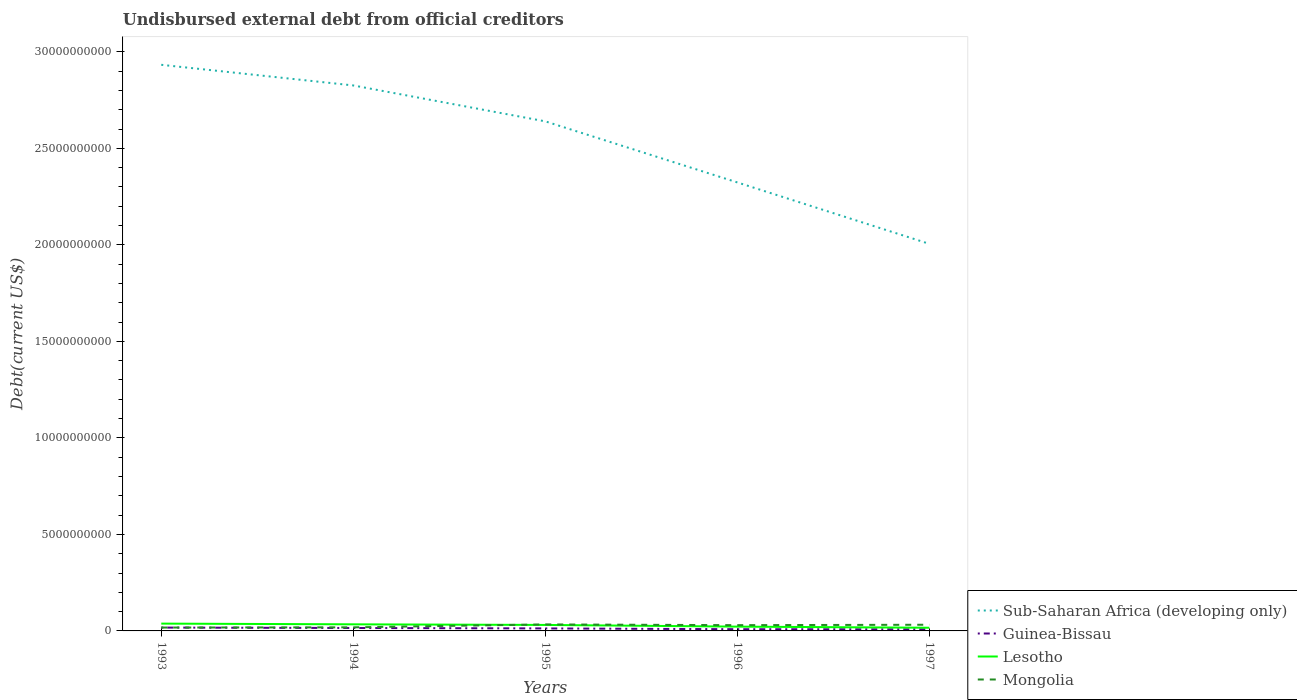How many different coloured lines are there?
Keep it short and to the point. 4. Across all years, what is the maximum total debt in Sub-Saharan Africa (developing only)?
Keep it short and to the point. 2.01e+1. In which year was the total debt in Sub-Saharan Africa (developing only) maximum?
Your response must be concise. 1997. What is the total total debt in Sub-Saharan Africa (developing only) in the graph?
Offer a very short reply. 6.09e+09. What is the difference between the highest and the second highest total debt in Guinea-Bissau?
Your answer should be compact. 8.95e+07. How many lines are there?
Offer a terse response. 4. What is the difference between two consecutive major ticks on the Y-axis?
Offer a terse response. 5.00e+09. Does the graph contain grids?
Provide a succinct answer. No. Where does the legend appear in the graph?
Keep it short and to the point. Bottom right. How are the legend labels stacked?
Provide a succinct answer. Vertical. What is the title of the graph?
Your answer should be compact. Undisbursed external debt from official creditors. Does "Guyana" appear as one of the legend labels in the graph?
Your answer should be compact. No. What is the label or title of the Y-axis?
Keep it short and to the point. Debt(current US$). What is the Debt(current US$) of Sub-Saharan Africa (developing only) in 1993?
Give a very brief answer. 2.93e+1. What is the Debt(current US$) in Guinea-Bissau in 1993?
Offer a very short reply. 1.73e+08. What is the Debt(current US$) in Lesotho in 1993?
Ensure brevity in your answer.  3.79e+08. What is the Debt(current US$) in Mongolia in 1993?
Provide a short and direct response. 1.74e+08. What is the Debt(current US$) of Sub-Saharan Africa (developing only) in 1994?
Your answer should be very brief. 2.83e+1. What is the Debt(current US$) of Guinea-Bissau in 1994?
Provide a succinct answer. 1.52e+08. What is the Debt(current US$) in Lesotho in 1994?
Ensure brevity in your answer.  3.41e+08. What is the Debt(current US$) in Mongolia in 1994?
Provide a short and direct response. 1.86e+08. What is the Debt(current US$) in Sub-Saharan Africa (developing only) in 1995?
Your answer should be compact. 2.64e+1. What is the Debt(current US$) of Guinea-Bissau in 1995?
Give a very brief answer. 1.30e+08. What is the Debt(current US$) in Lesotho in 1995?
Provide a succinct answer. 3.10e+08. What is the Debt(current US$) of Mongolia in 1995?
Provide a short and direct response. 3.37e+08. What is the Debt(current US$) of Sub-Saharan Africa (developing only) in 1996?
Offer a very short reply. 2.32e+1. What is the Debt(current US$) of Guinea-Bissau in 1996?
Keep it short and to the point. 8.90e+07. What is the Debt(current US$) in Lesotho in 1996?
Make the answer very short. 2.22e+08. What is the Debt(current US$) of Mongolia in 1996?
Your response must be concise. 2.99e+08. What is the Debt(current US$) in Sub-Saharan Africa (developing only) in 1997?
Make the answer very short. 2.01e+1. What is the Debt(current US$) in Guinea-Bissau in 1997?
Make the answer very short. 8.38e+07. What is the Debt(current US$) of Lesotho in 1997?
Provide a short and direct response. 1.65e+08. What is the Debt(current US$) of Mongolia in 1997?
Ensure brevity in your answer.  3.20e+08. Across all years, what is the maximum Debt(current US$) of Sub-Saharan Africa (developing only)?
Your response must be concise. 2.93e+1. Across all years, what is the maximum Debt(current US$) in Guinea-Bissau?
Keep it short and to the point. 1.73e+08. Across all years, what is the maximum Debt(current US$) in Lesotho?
Offer a terse response. 3.79e+08. Across all years, what is the maximum Debt(current US$) in Mongolia?
Give a very brief answer. 3.37e+08. Across all years, what is the minimum Debt(current US$) in Sub-Saharan Africa (developing only)?
Make the answer very short. 2.01e+1. Across all years, what is the minimum Debt(current US$) in Guinea-Bissau?
Offer a very short reply. 8.38e+07. Across all years, what is the minimum Debt(current US$) in Lesotho?
Your answer should be very brief. 1.65e+08. Across all years, what is the minimum Debt(current US$) of Mongolia?
Your answer should be compact. 1.74e+08. What is the total Debt(current US$) in Sub-Saharan Africa (developing only) in the graph?
Keep it short and to the point. 1.27e+11. What is the total Debt(current US$) of Guinea-Bissau in the graph?
Your answer should be very brief. 6.28e+08. What is the total Debt(current US$) of Lesotho in the graph?
Provide a succinct answer. 1.42e+09. What is the total Debt(current US$) of Mongolia in the graph?
Give a very brief answer. 1.32e+09. What is the difference between the Debt(current US$) of Sub-Saharan Africa (developing only) in 1993 and that in 1994?
Ensure brevity in your answer.  1.07e+09. What is the difference between the Debt(current US$) of Guinea-Bissau in 1993 and that in 1994?
Offer a very short reply. 2.16e+07. What is the difference between the Debt(current US$) of Lesotho in 1993 and that in 1994?
Keep it short and to the point. 3.74e+07. What is the difference between the Debt(current US$) of Mongolia in 1993 and that in 1994?
Your answer should be compact. -1.19e+07. What is the difference between the Debt(current US$) of Sub-Saharan Africa (developing only) in 1993 and that in 1995?
Ensure brevity in your answer.  2.93e+09. What is the difference between the Debt(current US$) of Guinea-Bissau in 1993 and that in 1995?
Provide a short and direct response. 4.35e+07. What is the difference between the Debt(current US$) in Lesotho in 1993 and that in 1995?
Keep it short and to the point. 6.91e+07. What is the difference between the Debt(current US$) in Mongolia in 1993 and that in 1995?
Make the answer very short. -1.63e+08. What is the difference between the Debt(current US$) in Sub-Saharan Africa (developing only) in 1993 and that in 1996?
Your answer should be very brief. 6.09e+09. What is the difference between the Debt(current US$) of Guinea-Bissau in 1993 and that in 1996?
Your answer should be compact. 8.43e+07. What is the difference between the Debt(current US$) of Lesotho in 1993 and that in 1996?
Provide a short and direct response. 1.56e+08. What is the difference between the Debt(current US$) in Mongolia in 1993 and that in 1996?
Keep it short and to the point. -1.25e+08. What is the difference between the Debt(current US$) in Sub-Saharan Africa (developing only) in 1993 and that in 1997?
Offer a terse response. 9.28e+09. What is the difference between the Debt(current US$) of Guinea-Bissau in 1993 and that in 1997?
Give a very brief answer. 8.95e+07. What is the difference between the Debt(current US$) in Lesotho in 1993 and that in 1997?
Ensure brevity in your answer.  2.14e+08. What is the difference between the Debt(current US$) in Mongolia in 1993 and that in 1997?
Ensure brevity in your answer.  -1.46e+08. What is the difference between the Debt(current US$) of Sub-Saharan Africa (developing only) in 1994 and that in 1995?
Your answer should be compact. 1.86e+09. What is the difference between the Debt(current US$) in Guinea-Bissau in 1994 and that in 1995?
Offer a terse response. 2.19e+07. What is the difference between the Debt(current US$) in Lesotho in 1994 and that in 1995?
Offer a very short reply. 3.17e+07. What is the difference between the Debt(current US$) in Mongolia in 1994 and that in 1995?
Your answer should be compact. -1.51e+08. What is the difference between the Debt(current US$) of Sub-Saharan Africa (developing only) in 1994 and that in 1996?
Your response must be concise. 5.02e+09. What is the difference between the Debt(current US$) of Guinea-Bissau in 1994 and that in 1996?
Ensure brevity in your answer.  6.27e+07. What is the difference between the Debt(current US$) in Lesotho in 1994 and that in 1996?
Your response must be concise. 1.19e+08. What is the difference between the Debt(current US$) of Mongolia in 1994 and that in 1996?
Ensure brevity in your answer.  -1.13e+08. What is the difference between the Debt(current US$) of Sub-Saharan Africa (developing only) in 1994 and that in 1997?
Make the answer very short. 8.21e+09. What is the difference between the Debt(current US$) in Guinea-Bissau in 1994 and that in 1997?
Offer a very short reply. 6.80e+07. What is the difference between the Debt(current US$) of Lesotho in 1994 and that in 1997?
Provide a short and direct response. 1.76e+08. What is the difference between the Debt(current US$) of Mongolia in 1994 and that in 1997?
Give a very brief answer. -1.34e+08. What is the difference between the Debt(current US$) of Sub-Saharan Africa (developing only) in 1995 and that in 1996?
Your answer should be very brief. 3.16e+09. What is the difference between the Debt(current US$) in Guinea-Bissau in 1995 and that in 1996?
Offer a terse response. 4.08e+07. What is the difference between the Debt(current US$) in Lesotho in 1995 and that in 1996?
Your response must be concise. 8.72e+07. What is the difference between the Debt(current US$) of Mongolia in 1995 and that in 1996?
Provide a succinct answer. 3.85e+07. What is the difference between the Debt(current US$) of Sub-Saharan Africa (developing only) in 1995 and that in 1997?
Your response must be concise. 6.35e+09. What is the difference between the Debt(current US$) of Guinea-Bissau in 1995 and that in 1997?
Your response must be concise. 4.61e+07. What is the difference between the Debt(current US$) of Lesotho in 1995 and that in 1997?
Provide a succinct answer. 1.44e+08. What is the difference between the Debt(current US$) in Mongolia in 1995 and that in 1997?
Ensure brevity in your answer.  1.72e+07. What is the difference between the Debt(current US$) in Sub-Saharan Africa (developing only) in 1996 and that in 1997?
Your answer should be compact. 3.18e+09. What is the difference between the Debt(current US$) of Guinea-Bissau in 1996 and that in 1997?
Keep it short and to the point. 5.23e+06. What is the difference between the Debt(current US$) in Lesotho in 1996 and that in 1997?
Ensure brevity in your answer.  5.73e+07. What is the difference between the Debt(current US$) of Mongolia in 1996 and that in 1997?
Provide a succinct answer. -2.14e+07. What is the difference between the Debt(current US$) of Sub-Saharan Africa (developing only) in 1993 and the Debt(current US$) of Guinea-Bissau in 1994?
Your answer should be compact. 2.92e+1. What is the difference between the Debt(current US$) of Sub-Saharan Africa (developing only) in 1993 and the Debt(current US$) of Lesotho in 1994?
Ensure brevity in your answer.  2.90e+1. What is the difference between the Debt(current US$) in Sub-Saharan Africa (developing only) in 1993 and the Debt(current US$) in Mongolia in 1994?
Provide a succinct answer. 2.91e+1. What is the difference between the Debt(current US$) in Guinea-Bissau in 1993 and the Debt(current US$) in Lesotho in 1994?
Your response must be concise. -1.68e+08. What is the difference between the Debt(current US$) in Guinea-Bissau in 1993 and the Debt(current US$) in Mongolia in 1994?
Your answer should be very brief. -1.27e+07. What is the difference between the Debt(current US$) in Lesotho in 1993 and the Debt(current US$) in Mongolia in 1994?
Provide a short and direct response. 1.93e+08. What is the difference between the Debt(current US$) in Sub-Saharan Africa (developing only) in 1993 and the Debt(current US$) in Guinea-Bissau in 1995?
Offer a terse response. 2.92e+1. What is the difference between the Debt(current US$) of Sub-Saharan Africa (developing only) in 1993 and the Debt(current US$) of Lesotho in 1995?
Your response must be concise. 2.90e+1. What is the difference between the Debt(current US$) in Sub-Saharan Africa (developing only) in 1993 and the Debt(current US$) in Mongolia in 1995?
Make the answer very short. 2.90e+1. What is the difference between the Debt(current US$) in Guinea-Bissau in 1993 and the Debt(current US$) in Lesotho in 1995?
Provide a short and direct response. -1.36e+08. What is the difference between the Debt(current US$) in Guinea-Bissau in 1993 and the Debt(current US$) in Mongolia in 1995?
Offer a terse response. -1.64e+08. What is the difference between the Debt(current US$) of Lesotho in 1993 and the Debt(current US$) of Mongolia in 1995?
Make the answer very short. 4.16e+07. What is the difference between the Debt(current US$) in Sub-Saharan Africa (developing only) in 1993 and the Debt(current US$) in Guinea-Bissau in 1996?
Ensure brevity in your answer.  2.92e+1. What is the difference between the Debt(current US$) of Sub-Saharan Africa (developing only) in 1993 and the Debt(current US$) of Lesotho in 1996?
Offer a terse response. 2.91e+1. What is the difference between the Debt(current US$) of Sub-Saharan Africa (developing only) in 1993 and the Debt(current US$) of Mongolia in 1996?
Keep it short and to the point. 2.90e+1. What is the difference between the Debt(current US$) of Guinea-Bissau in 1993 and the Debt(current US$) of Lesotho in 1996?
Give a very brief answer. -4.92e+07. What is the difference between the Debt(current US$) in Guinea-Bissau in 1993 and the Debt(current US$) in Mongolia in 1996?
Make the answer very short. -1.25e+08. What is the difference between the Debt(current US$) of Lesotho in 1993 and the Debt(current US$) of Mongolia in 1996?
Your response must be concise. 8.01e+07. What is the difference between the Debt(current US$) in Sub-Saharan Africa (developing only) in 1993 and the Debt(current US$) in Guinea-Bissau in 1997?
Your response must be concise. 2.92e+1. What is the difference between the Debt(current US$) of Sub-Saharan Africa (developing only) in 1993 and the Debt(current US$) of Lesotho in 1997?
Provide a succinct answer. 2.92e+1. What is the difference between the Debt(current US$) of Sub-Saharan Africa (developing only) in 1993 and the Debt(current US$) of Mongolia in 1997?
Provide a short and direct response. 2.90e+1. What is the difference between the Debt(current US$) in Guinea-Bissau in 1993 and the Debt(current US$) in Lesotho in 1997?
Offer a terse response. 8.10e+06. What is the difference between the Debt(current US$) of Guinea-Bissau in 1993 and the Debt(current US$) of Mongolia in 1997?
Offer a terse response. -1.47e+08. What is the difference between the Debt(current US$) in Lesotho in 1993 and the Debt(current US$) in Mongolia in 1997?
Give a very brief answer. 5.87e+07. What is the difference between the Debt(current US$) in Sub-Saharan Africa (developing only) in 1994 and the Debt(current US$) in Guinea-Bissau in 1995?
Keep it short and to the point. 2.81e+1. What is the difference between the Debt(current US$) in Sub-Saharan Africa (developing only) in 1994 and the Debt(current US$) in Lesotho in 1995?
Provide a succinct answer. 2.80e+1. What is the difference between the Debt(current US$) of Sub-Saharan Africa (developing only) in 1994 and the Debt(current US$) of Mongolia in 1995?
Ensure brevity in your answer.  2.79e+1. What is the difference between the Debt(current US$) in Guinea-Bissau in 1994 and the Debt(current US$) in Lesotho in 1995?
Your response must be concise. -1.58e+08. What is the difference between the Debt(current US$) of Guinea-Bissau in 1994 and the Debt(current US$) of Mongolia in 1995?
Provide a succinct answer. -1.85e+08. What is the difference between the Debt(current US$) in Lesotho in 1994 and the Debt(current US$) in Mongolia in 1995?
Offer a very short reply. 4.15e+06. What is the difference between the Debt(current US$) of Sub-Saharan Africa (developing only) in 1994 and the Debt(current US$) of Guinea-Bissau in 1996?
Keep it short and to the point. 2.82e+1. What is the difference between the Debt(current US$) in Sub-Saharan Africa (developing only) in 1994 and the Debt(current US$) in Lesotho in 1996?
Your answer should be compact. 2.80e+1. What is the difference between the Debt(current US$) of Sub-Saharan Africa (developing only) in 1994 and the Debt(current US$) of Mongolia in 1996?
Offer a terse response. 2.80e+1. What is the difference between the Debt(current US$) in Guinea-Bissau in 1994 and the Debt(current US$) in Lesotho in 1996?
Your response must be concise. -7.07e+07. What is the difference between the Debt(current US$) of Guinea-Bissau in 1994 and the Debt(current US$) of Mongolia in 1996?
Offer a very short reply. -1.47e+08. What is the difference between the Debt(current US$) in Lesotho in 1994 and the Debt(current US$) in Mongolia in 1996?
Your answer should be very brief. 4.27e+07. What is the difference between the Debt(current US$) in Sub-Saharan Africa (developing only) in 1994 and the Debt(current US$) in Guinea-Bissau in 1997?
Keep it short and to the point. 2.82e+1. What is the difference between the Debt(current US$) of Sub-Saharan Africa (developing only) in 1994 and the Debt(current US$) of Lesotho in 1997?
Give a very brief answer. 2.81e+1. What is the difference between the Debt(current US$) in Sub-Saharan Africa (developing only) in 1994 and the Debt(current US$) in Mongolia in 1997?
Give a very brief answer. 2.79e+1. What is the difference between the Debt(current US$) in Guinea-Bissau in 1994 and the Debt(current US$) in Lesotho in 1997?
Keep it short and to the point. -1.35e+07. What is the difference between the Debt(current US$) of Guinea-Bissau in 1994 and the Debt(current US$) of Mongolia in 1997?
Offer a very short reply. -1.68e+08. What is the difference between the Debt(current US$) in Lesotho in 1994 and the Debt(current US$) in Mongolia in 1997?
Your answer should be very brief. 2.13e+07. What is the difference between the Debt(current US$) in Sub-Saharan Africa (developing only) in 1995 and the Debt(current US$) in Guinea-Bissau in 1996?
Keep it short and to the point. 2.63e+1. What is the difference between the Debt(current US$) of Sub-Saharan Africa (developing only) in 1995 and the Debt(current US$) of Lesotho in 1996?
Offer a terse response. 2.62e+1. What is the difference between the Debt(current US$) in Sub-Saharan Africa (developing only) in 1995 and the Debt(current US$) in Mongolia in 1996?
Your response must be concise. 2.61e+1. What is the difference between the Debt(current US$) in Guinea-Bissau in 1995 and the Debt(current US$) in Lesotho in 1996?
Make the answer very short. -9.26e+07. What is the difference between the Debt(current US$) in Guinea-Bissau in 1995 and the Debt(current US$) in Mongolia in 1996?
Offer a very short reply. -1.69e+08. What is the difference between the Debt(current US$) in Lesotho in 1995 and the Debt(current US$) in Mongolia in 1996?
Ensure brevity in your answer.  1.10e+07. What is the difference between the Debt(current US$) in Sub-Saharan Africa (developing only) in 1995 and the Debt(current US$) in Guinea-Bissau in 1997?
Offer a terse response. 2.63e+1. What is the difference between the Debt(current US$) in Sub-Saharan Africa (developing only) in 1995 and the Debt(current US$) in Lesotho in 1997?
Offer a very short reply. 2.62e+1. What is the difference between the Debt(current US$) of Sub-Saharan Africa (developing only) in 1995 and the Debt(current US$) of Mongolia in 1997?
Keep it short and to the point. 2.61e+1. What is the difference between the Debt(current US$) in Guinea-Bissau in 1995 and the Debt(current US$) in Lesotho in 1997?
Offer a very short reply. -3.54e+07. What is the difference between the Debt(current US$) in Guinea-Bissau in 1995 and the Debt(current US$) in Mongolia in 1997?
Your response must be concise. -1.90e+08. What is the difference between the Debt(current US$) of Lesotho in 1995 and the Debt(current US$) of Mongolia in 1997?
Offer a terse response. -1.04e+07. What is the difference between the Debt(current US$) in Sub-Saharan Africa (developing only) in 1996 and the Debt(current US$) in Guinea-Bissau in 1997?
Ensure brevity in your answer.  2.32e+1. What is the difference between the Debt(current US$) in Sub-Saharan Africa (developing only) in 1996 and the Debt(current US$) in Lesotho in 1997?
Ensure brevity in your answer.  2.31e+1. What is the difference between the Debt(current US$) in Sub-Saharan Africa (developing only) in 1996 and the Debt(current US$) in Mongolia in 1997?
Offer a very short reply. 2.29e+1. What is the difference between the Debt(current US$) of Guinea-Bissau in 1996 and the Debt(current US$) of Lesotho in 1997?
Your response must be concise. -7.62e+07. What is the difference between the Debt(current US$) in Guinea-Bissau in 1996 and the Debt(current US$) in Mongolia in 1997?
Offer a very short reply. -2.31e+08. What is the difference between the Debt(current US$) in Lesotho in 1996 and the Debt(current US$) in Mongolia in 1997?
Give a very brief answer. -9.76e+07. What is the average Debt(current US$) in Sub-Saharan Africa (developing only) per year?
Make the answer very short. 2.55e+1. What is the average Debt(current US$) of Guinea-Bissau per year?
Provide a short and direct response. 1.26e+08. What is the average Debt(current US$) of Lesotho per year?
Give a very brief answer. 2.83e+08. What is the average Debt(current US$) of Mongolia per year?
Your response must be concise. 2.63e+08. In the year 1993, what is the difference between the Debt(current US$) in Sub-Saharan Africa (developing only) and Debt(current US$) in Guinea-Bissau?
Your response must be concise. 2.92e+1. In the year 1993, what is the difference between the Debt(current US$) in Sub-Saharan Africa (developing only) and Debt(current US$) in Lesotho?
Your answer should be very brief. 2.90e+1. In the year 1993, what is the difference between the Debt(current US$) of Sub-Saharan Africa (developing only) and Debt(current US$) of Mongolia?
Offer a terse response. 2.92e+1. In the year 1993, what is the difference between the Debt(current US$) of Guinea-Bissau and Debt(current US$) of Lesotho?
Provide a short and direct response. -2.05e+08. In the year 1993, what is the difference between the Debt(current US$) of Guinea-Bissau and Debt(current US$) of Mongolia?
Ensure brevity in your answer.  -8.41e+05. In the year 1993, what is the difference between the Debt(current US$) of Lesotho and Debt(current US$) of Mongolia?
Ensure brevity in your answer.  2.05e+08. In the year 1994, what is the difference between the Debt(current US$) in Sub-Saharan Africa (developing only) and Debt(current US$) in Guinea-Bissau?
Make the answer very short. 2.81e+1. In the year 1994, what is the difference between the Debt(current US$) of Sub-Saharan Africa (developing only) and Debt(current US$) of Lesotho?
Give a very brief answer. 2.79e+1. In the year 1994, what is the difference between the Debt(current US$) in Sub-Saharan Africa (developing only) and Debt(current US$) in Mongolia?
Keep it short and to the point. 2.81e+1. In the year 1994, what is the difference between the Debt(current US$) in Guinea-Bissau and Debt(current US$) in Lesotho?
Offer a terse response. -1.90e+08. In the year 1994, what is the difference between the Debt(current US$) of Guinea-Bissau and Debt(current US$) of Mongolia?
Provide a succinct answer. -3.43e+07. In the year 1994, what is the difference between the Debt(current US$) of Lesotho and Debt(current US$) of Mongolia?
Your answer should be very brief. 1.55e+08. In the year 1995, what is the difference between the Debt(current US$) of Sub-Saharan Africa (developing only) and Debt(current US$) of Guinea-Bissau?
Your answer should be compact. 2.63e+1. In the year 1995, what is the difference between the Debt(current US$) in Sub-Saharan Africa (developing only) and Debt(current US$) in Lesotho?
Provide a succinct answer. 2.61e+1. In the year 1995, what is the difference between the Debt(current US$) of Sub-Saharan Africa (developing only) and Debt(current US$) of Mongolia?
Your response must be concise. 2.61e+1. In the year 1995, what is the difference between the Debt(current US$) in Guinea-Bissau and Debt(current US$) in Lesotho?
Provide a succinct answer. -1.80e+08. In the year 1995, what is the difference between the Debt(current US$) in Guinea-Bissau and Debt(current US$) in Mongolia?
Provide a short and direct response. -2.07e+08. In the year 1995, what is the difference between the Debt(current US$) of Lesotho and Debt(current US$) of Mongolia?
Offer a very short reply. -2.75e+07. In the year 1996, what is the difference between the Debt(current US$) of Sub-Saharan Africa (developing only) and Debt(current US$) of Guinea-Bissau?
Offer a very short reply. 2.31e+1. In the year 1996, what is the difference between the Debt(current US$) in Sub-Saharan Africa (developing only) and Debt(current US$) in Lesotho?
Ensure brevity in your answer.  2.30e+1. In the year 1996, what is the difference between the Debt(current US$) of Sub-Saharan Africa (developing only) and Debt(current US$) of Mongolia?
Your answer should be compact. 2.29e+1. In the year 1996, what is the difference between the Debt(current US$) in Guinea-Bissau and Debt(current US$) in Lesotho?
Your answer should be very brief. -1.33e+08. In the year 1996, what is the difference between the Debt(current US$) of Guinea-Bissau and Debt(current US$) of Mongolia?
Your response must be concise. -2.10e+08. In the year 1996, what is the difference between the Debt(current US$) in Lesotho and Debt(current US$) in Mongolia?
Your response must be concise. -7.62e+07. In the year 1997, what is the difference between the Debt(current US$) of Sub-Saharan Africa (developing only) and Debt(current US$) of Guinea-Bissau?
Give a very brief answer. 2.00e+1. In the year 1997, what is the difference between the Debt(current US$) of Sub-Saharan Africa (developing only) and Debt(current US$) of Lesotho?
Ensure brevity in your answer.  1.99e+1. In the year 1997, what is the difference between the Debt(current US$) of Sub-Saharan Africa (developing only) and Debt(current US$) of Mongolia?
Your response must be concise. 1.97e+1. In the year 1997, what is the difference between the Debt(current US$) of Guinea-Bissau and Debt(current US$) of Lesotho?
Keep it short and to the point. -8.14e+07. In the year 1997, what is the difference between the Debt(current US$) of Guinea-Bissau and Debt(current US$) of Mongolia?
Your answer should be compact. -2.36e+08. In the year 1997, what is the difference between the Debt(current US$) in Lesotho and Debt(current US$) in Mongolia?
Your response must be concise. -1.55e+08. What is the ratio of the Debt(current US$) of Sub-Saharan Africa (developing only) in 1993 to that in 1994?
Keep it short and to the point. 1.04. What is the ratio of the Debt(current US$) of Guinea-Bissau in 1993 to that in 1994?
Your answer should be very brief. 1.14. What is the ratio of the Debt(current US$) of Lesotho in 1993 to that in 1994?
Your answer should be very brief. 1.11. What is the ratio of the Debt(current US$) in Mongolia in 1993 to that in 1994?
Provide a short and direct response. 0.94. What is the ratio of the Debt(current US$) in Sub-Saharan Africa (developing only) in 1993 to that in 1995?
Give a very brief answer. 1.11. What is the ratio of the Debt(current US$) of Guinea-Bissau in 1993 to that in 1995?
Offer a terse response. 1.33. What is the ratio of the Debt(current US$) of Lesotho in 1993 to that in 1995?
Offer a terse response. 1.22. What is the ratio of the Debt(current US$) of Mongolia in 1993 to that in 1995?
Provide a short and direct response. 0.52. What is the ratio of the Debt(current US$) of Sub-Saharan Africa (developing only) in 1993 to that in 1996?
Give a very brief answer. 1.26. What is the ratio of the Debt(current US$) of Guinea-Bissau in 1993 to that in 1996?
Keep it short and to the point. 1.95. What is the ratio of the Debt(current US$) in Lesotho in 1993 to that in 1996?
Your answer should be very brief. 1.7. What is the ratio of the Debt(current US$) in Mongolia in 1993 to that in 1996?
Keep it short and to the point. 0.58. What is the ratio of the Debt(current US$) in Sub-Saharan Africa (developing only) in 1993 to that in 1997?
Give a very brief answer. 1.46. What is the ratio of the Debt(current US$) of Guinea-Bissau in 1993 to that in 1997?
Make the answer very short. 2.07. What is the ratio of the Debt(current US$) of Lesotho in 1993 to that in 1997?
Your response must be concise. 2.29. What is the ratio of the Debt(current US$) of Mongolia in 1993 to that in 1997?
Make the answer very short. 0.54. What is the ratio of the Debt(current US$) of Sub-Saharan Africa (developing only) in 1994 to that in 1995?
Offer a very short reply. 1.07. What is the ratio of the Debt(current US$) of Guinea-Bissau in 1994 to that in 1995?
Your response must be concise. 1.17. What is the ratio of the Debt(current US$) in Lesotho in 1994 to that in 1995?
Offer a terse response. 1.1. What is the ratio of the Debt(current US$) in Mongolia in 1994 to that in 1995?
Provide a short and direct response. 0.55. What is the ratio of the Debt(current US$) in Sub-Saharan Africa (developing only) in 1994 to that in 1996?
Make the answer very short. 1.22. What is the ratio of the Debt(current US$) of Guinea-Bissau in 1994 to that in 1996?
Offer a terse response. 1.7. What is the ratio of the Debt(current US$) of Lesotho in 1994 to that in 1996?
Offer a very short reply. 1.53. What is the ratio of the Debt(current US$) in Mongolia in 1994 to that in 1996?
Provide a short and direct response. 0.62. What is the ratio of the Debt(current US$) in Sub-Saharan Africa (developing only) in 1994 to that in 1997?
Keep it short and to the point. 1.41. What is the ratio of the Debt(current US$) of Guinea-Bissau in 1994 to that in 1997?
Give a very brief answer. 1.81. What is the ratio of the Debt(current US$) in Lesotho in 1994 to that in 1997?
Offer a terse response. 2.07. What is the ratio of the Debt(current US$) of Mongolia in 1994 to that in 1997?
Offer a terse response. 0.58. What is the ratio of the Debt(current US$) in Sub-Saharan Africa (developing only) in 1995 to that in 1996?
Offer a terse response. 1.14. What is the ratio of the Debt(current US$) of Guinea-Bissau in 1995 to that in 1996?
Give a very brief answer. 1.46. What is the ratio of the Debt(current US$) of Lesotho in 1995 to that in 1996?
Make the answer very short. 1.39. What is the ratio of the Debt(current US$) of Mongolia in 1995 to that in 1996?
Make the answer very short. 1.13. What is the ratio of the Debt(current US$) of Sub-Saharan Africa (developing only) in 1995 to that in 1997?
Keep it short and to the point. 1.32. What is the ratio of the Debt(current US$) of Guinea-Bissau in 1995 to that in 1997?
Give a very brief answer. 1.55. What is the ratio of the Debt(current US$) in Lesotho in 1995 to that in 1997?
Your answer should be compact. 1.87. What is the ratio of the Debt(current US$) of Mongolia in 1995 to that in 1997?
Keep it short and to the point. 1.05. What is the ratio of the Debt(current US$) of Sub-Saharan Africa (developing only) in 1996 to that in 1997?
Your answer should be compact. 1.16. What is the ratio of the Debt(current US$) of Lesotho in 1996 to that in 1997?
Provide a short and direct response. 1.35. What is the ratio of the Debt(current US$) of Mongolia in 1996 to that in 1997?
Your response must be concise. 0.93. What is the difference between the highest and the second highest Debt(current US$) of Sub-Saharan Africa (developing only)?
Make the answer very short. 1.07e+09. What is the difference between the highest and the second highest Debt(current US$) of Guinea-Bissau?
Your answer should be compact. 2.16e+07. What is the difference between the highest and the second highest Debt(current US$) in Lesotho?
Offer a very short reply. 3.74e+07. What is the difference between the highest and the second highest Debt(current US$) in Mongolia?
Give a very brief answer. 1.72e+07. What is the difference between the highest and the lowest Debt(current US$) in Sub-Saharan Africa (developing only)?
Your answer should be very brief. 9.28e+09. What is the difference between the highest and the lowest Debt(current US$) of Guinea-Bissau?
Offer a terse response. 8.95e+07. What is the difference between the highest and the lowest Debt(current US$) in Lesotho?
Offer a very short reply. 2.14e+08. What is the difference between the highest and the lowest Debt(current US$) in Mongolia?
Provide a succinct answer. 1.63e+08. 